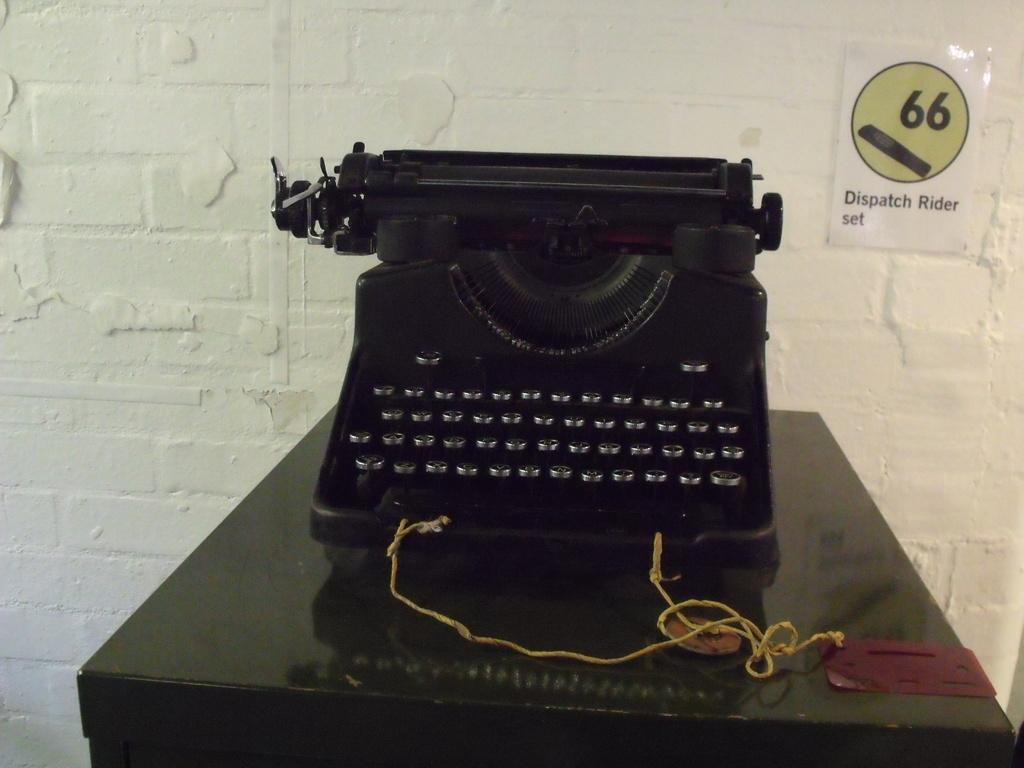What is the main object in the image? There is a typewriter in the image. What is the typewriter placed on? The typewriter is on a wooden table. What can be seen behind the wooden table? The wooden table is in front of a white wall. Can you see a tiger walking across the white wall in the image? No, there is no tiger present in the image. 